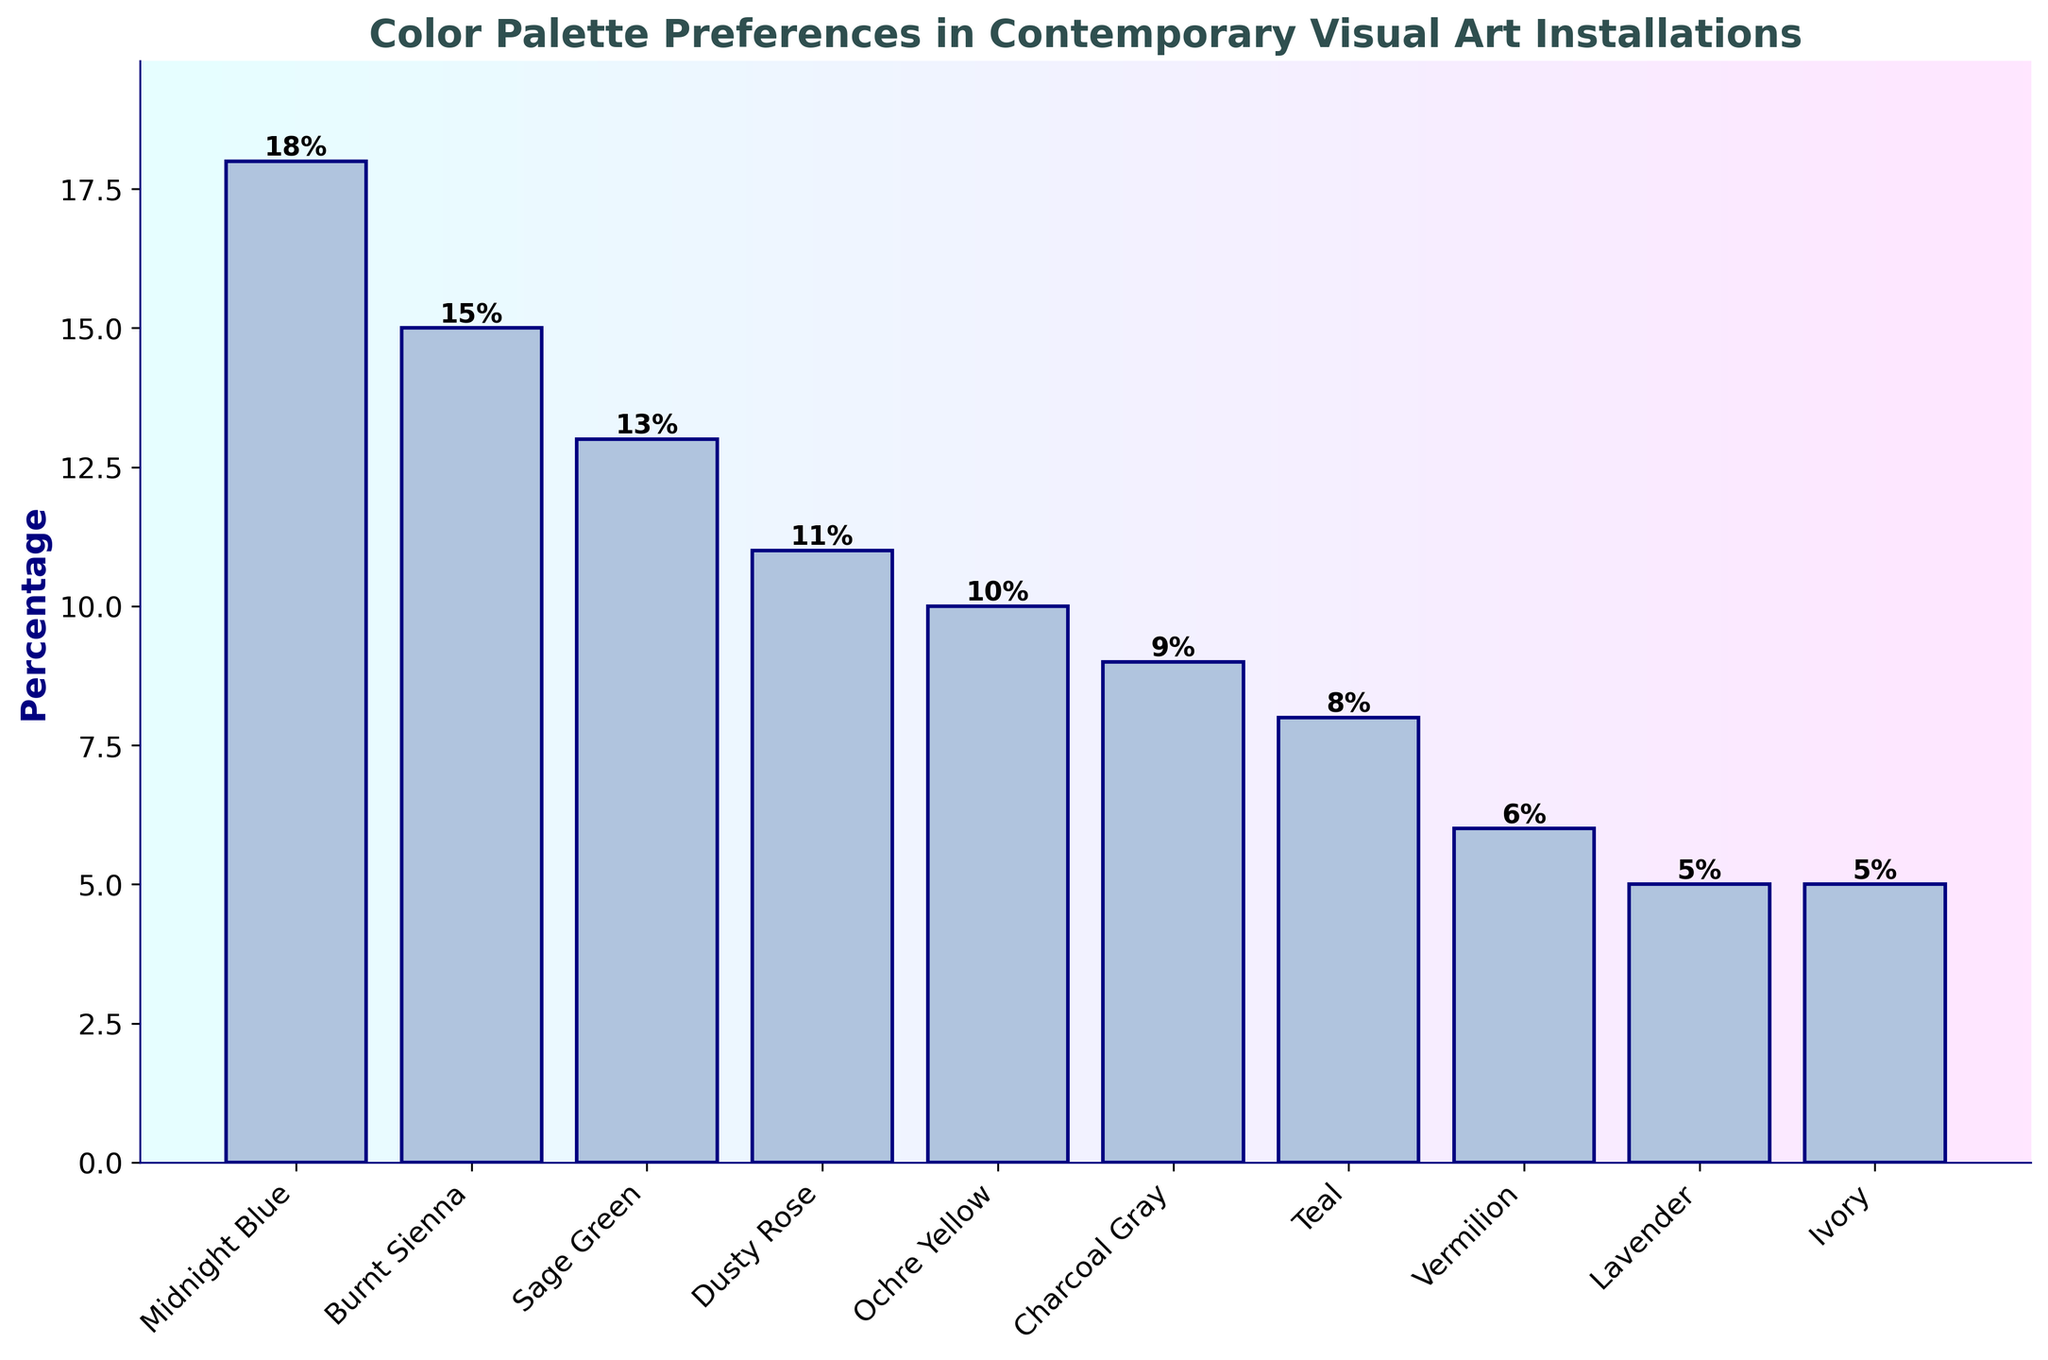Which color has the highest percentage in the chart? The highest bar on the chart represents the color with the highest percentage. Midnight Blue has the highest bar at 18%.
Answer: Midnight Blue Which color has the lowest percentage in the chart? The shortest bars on the chart indicate the colors with the lowest percentages. Ivory and Lavender both have bars at 5%.
Answer: Ivory and Lavender What is the combined percentage of the two least preferred colors? Sum the percentages of the least preferred colors. Ivory has 5% and Lavender has 5%, so combined they make 5% + 5%.
Answer: 10% How much higher is the percentage of Midnight Blue compared to Teal? Subtract the percentage of Teal from that of Midnight Blue. Midnight Blue is 18% and Teal is 8%, so 18% - 8%.
Answer: 10% What is the average percentage of the top three preferred colors? Add the percentages of the top three colors and divide by 3. Midnight Blue (18%) + Burnt Sienna (15%) + Sage Green (13%) = 46%; 46% / 3.
Answer: 15.33% Which color is more preferred, Vermilion or Charcoal Gray? Compare the heights of the bars for Vermilion and Charcoal Gray. Charcoal Gray is 9% and Vermilion is 6%.
Answer: Charcoal Gray How does the percentage of Ochre Yellow compare to Dusty Rose? Ochre Yellow has a bar with 10% and Dusty Rose has a bar with 11%. Dusty Rose is 1% higher.
Answer: Dusty Rose is higher What is the median percentage among all the colors? Sort the percentages in ascending order and find the middle value. The sorted percentages are: 5%, 5%, 6%, 8%, 9%, 10%, 11%, 13%, 15%, 18%. The median is the average of the 5th and 6th values. (9% + 10%) / 2.
Answer: 9.5% Which color occupies the midpoint in terms of visual preference percentages? Arrange the colors in ascending order based on percentages. The colors in order are Ivory, Lavender, Vermilion, Teal, Charcoal Gray, Ochre Yellow, Dusty Rose, Sage Green, Burnt Sienna, Midnight Blue. Charcoal Gray, being fifth in the list, occupies the midpoint.
Answer: Charcoal Gray By how much does the percentage of the most preferred color exceed the median percentage? Subtract the median percentage from the percentage of Midnight Blue. Midnight Blue is 18%, and the median is 9.5%. So, 18% - 9.5%.
Answer: 8.5% 